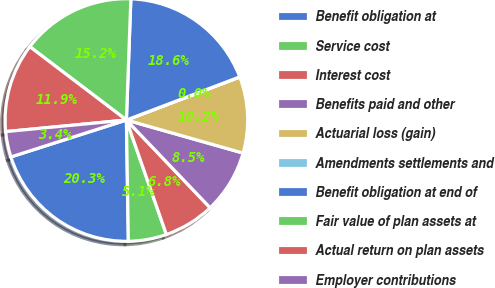<chart> <loc_0><loc_0><loc_500><loc_500><pie_chart><fcel>Benefit obligation at<fcel>Service cost<fcel>Interest cost<fcel>Benefits paid and other<fcel>Actuarial loss (gain)<fcel>Amendments settlements and<fcel>Benefit obligation at end of<fcel>Fair value of plan assets at<fcel>Actual return on plan assets<fcel>Employer contributions<nl><fcel>20.33%<fcel>5.09%<fcel>6.78%<fcel>8.48%<fcel>10.17%<fcel>0.01%<fcel>18.63%<fcel>15.25%<fcel>11.86%<fcel>3.4%<nl></chart> 